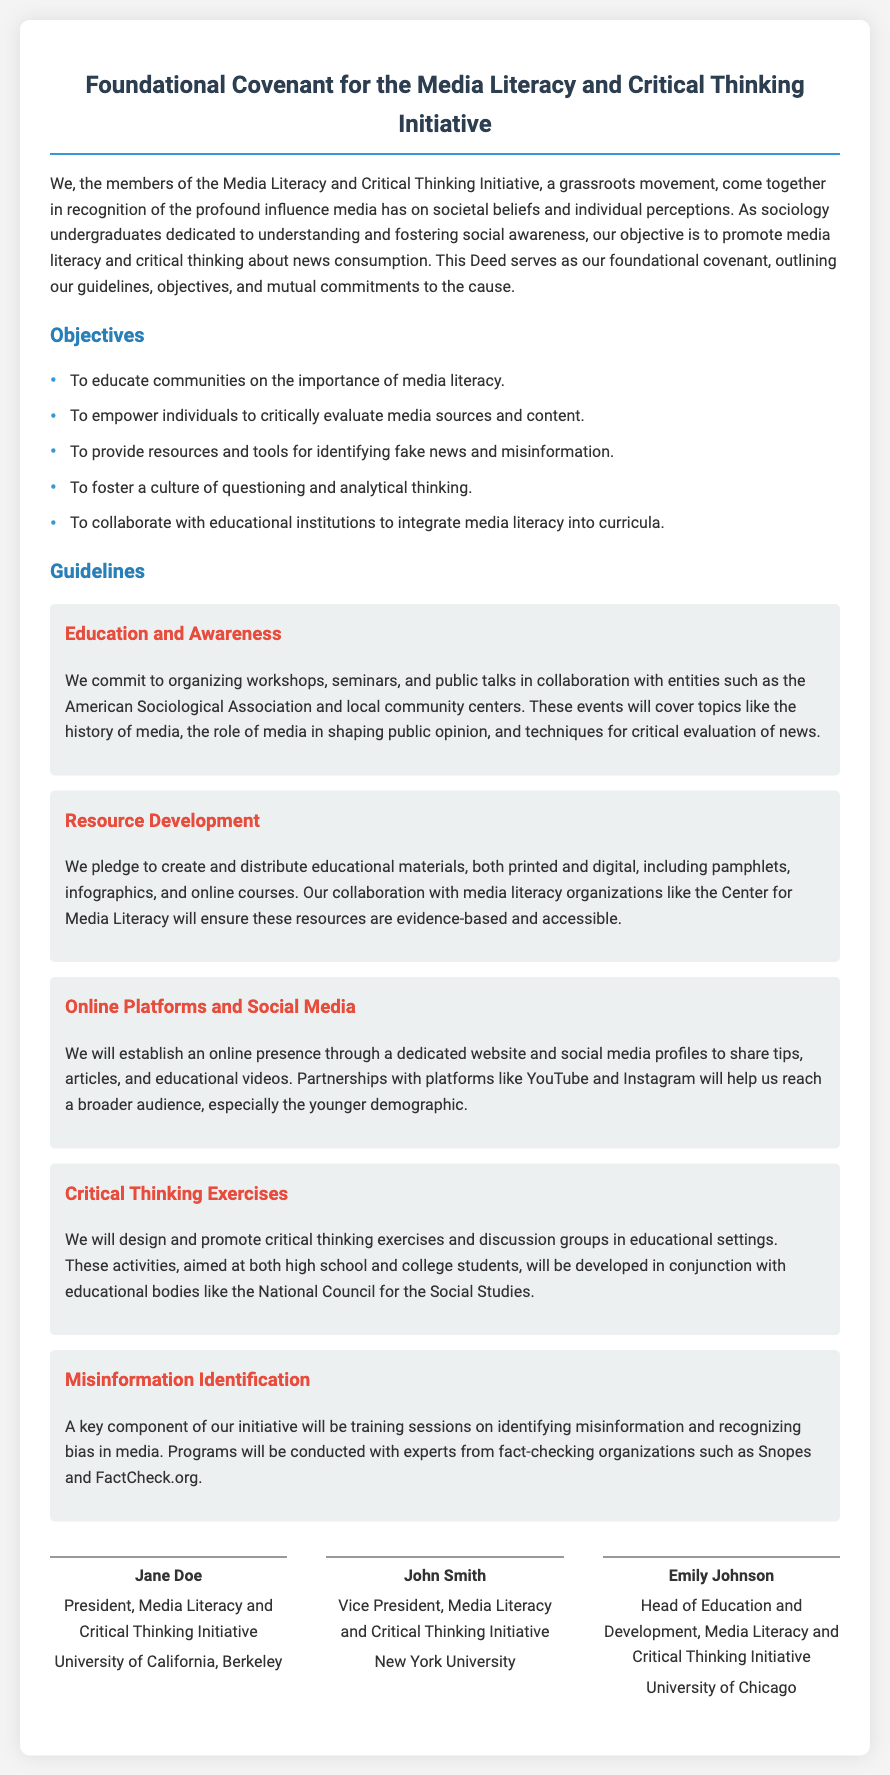What is the title of the document? The title of the document is presented prominently at the top of the document.
Answer: Foundational Covenant for the Media Literacy and Critical Thinking Initiative How many objectives are outlined in the document? The document lists several objectives under the section titled "Objectives."
Answer: Five Who is the President of the Media Literacy and Critical Thinking Initiative? The document provides the name and title of the individuals who signed the deed at the end.
Answer: Jane Doe Which university is associated with the Vice President? The document specifies the university affiliation of the Vice President after their name.
Answer: New York University What type of initiatives are mentioned under the "Guidelines"? The "Guidelines" section includes various specific initiatives related to education and media literacy.
Answer: Workshops, Resource Development, Online Platforms and Social Media, Critical Thinking Exercises, Misinformation Identification What organization is mentioned as a partner in developing educational resources? The document mentions partnerships with specific organizations under the "Resource Development" guideline.
Answer: Center for Media Literacy What is one of the specific commitments made regarding misinformation? The document details plans to conduct training sessions focused on media evaluation.
Answer: Training sessions on identifying misinformation Who is the Head of Education and Development? The document lists the name and title of the individual responsible for this role.
Answer: Emily Johnson 